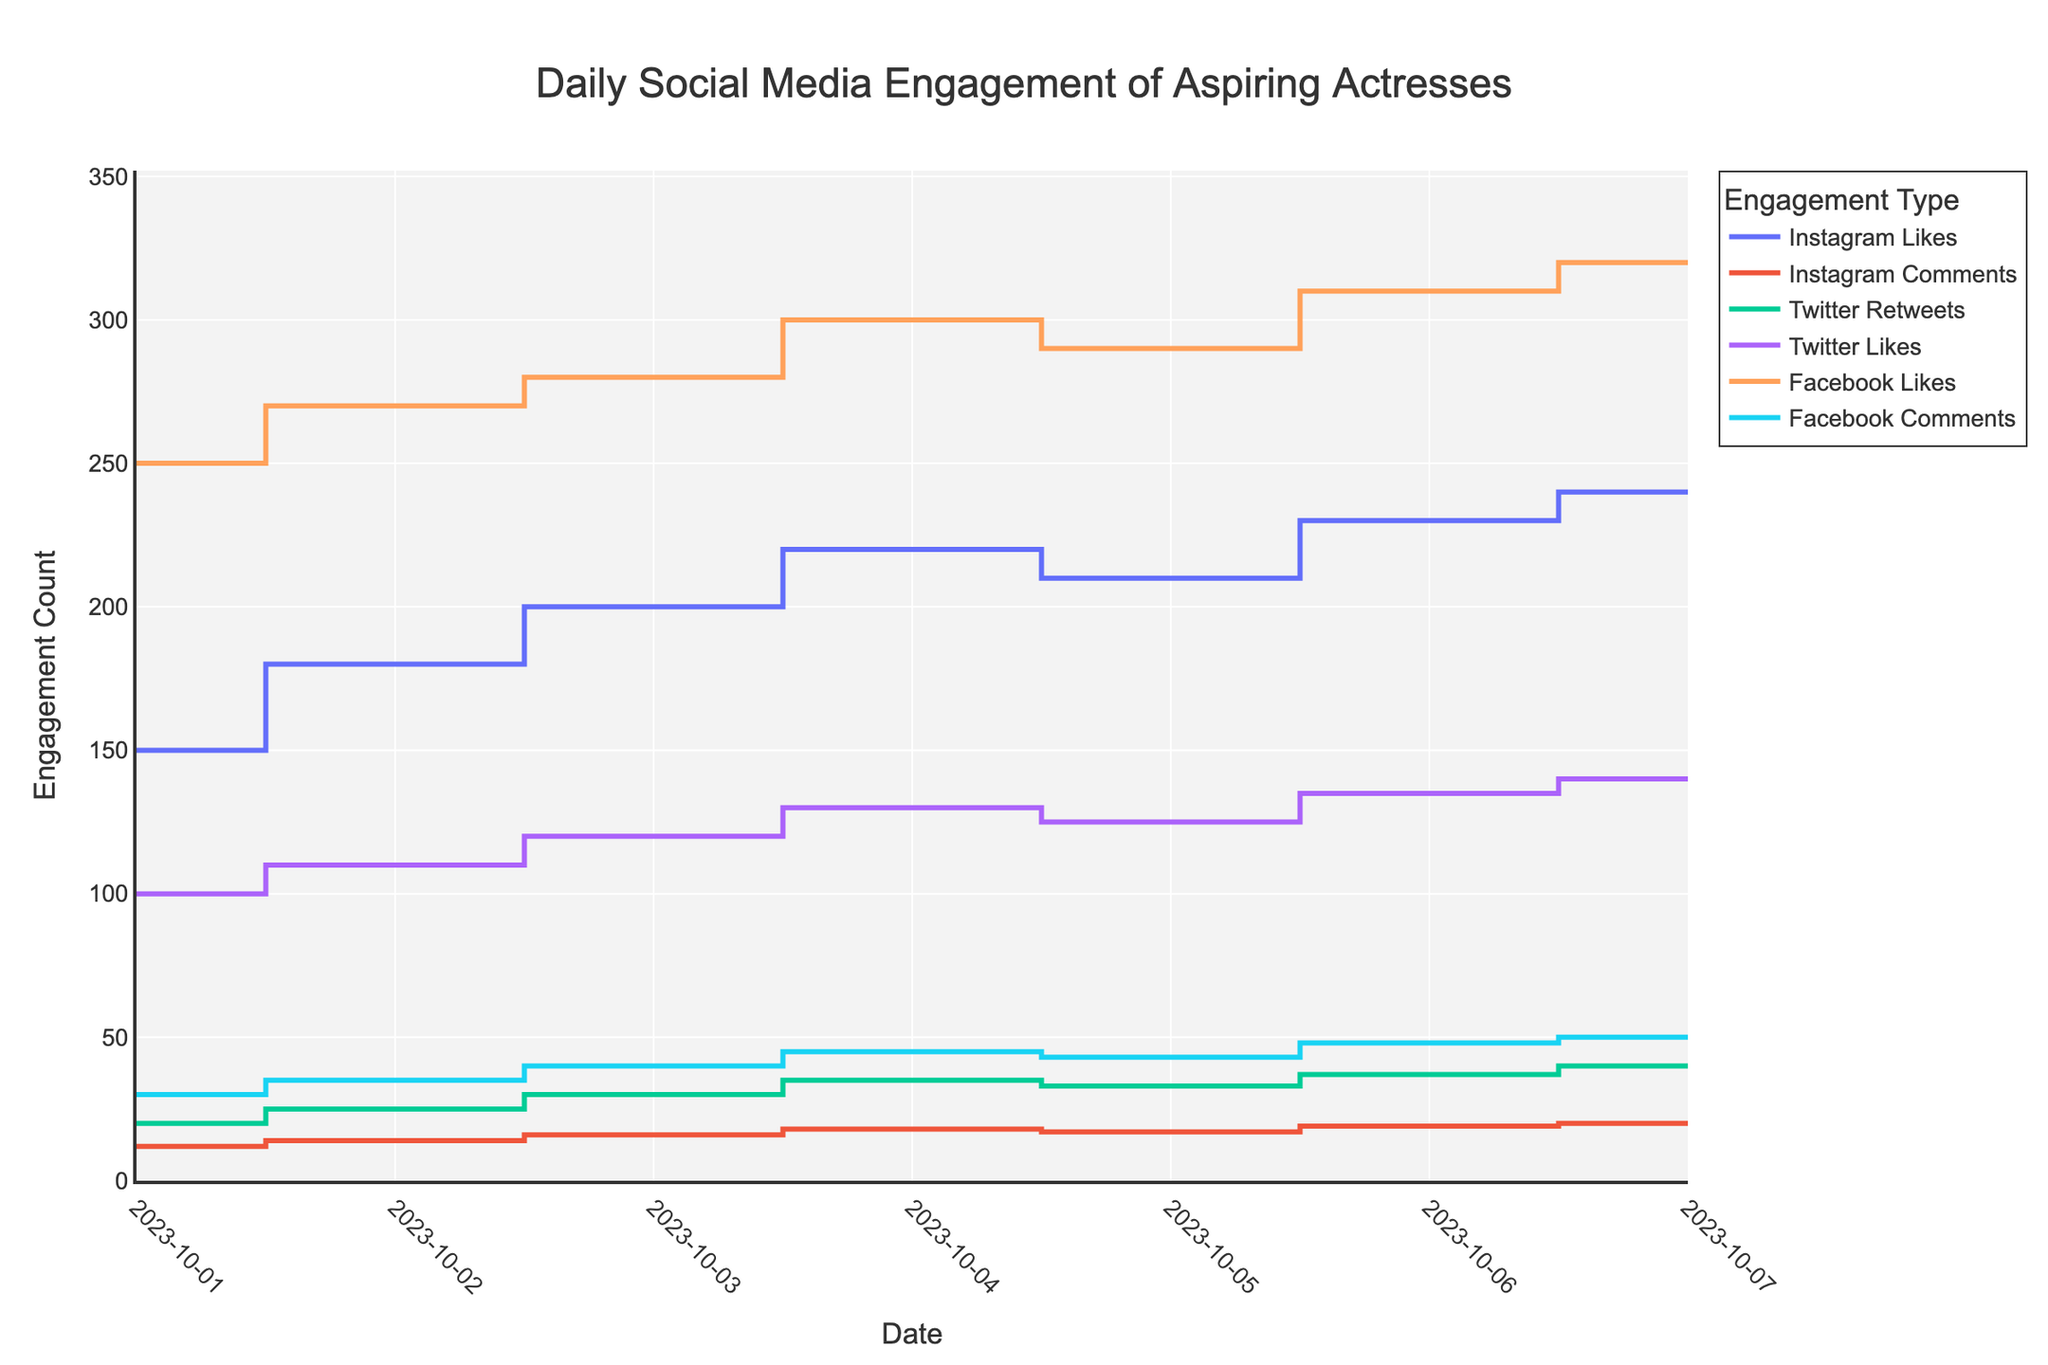What's the title of the plot? The title is located at the top of the figure and describes the main topic of the plot.
Answer: Daily Social Media Engagement of Aspiring Actresses What is the highest engagement count recorded for Instagram Likes? The highest point on the stair plot line for Instagram Likes gives us the value for the maximum engagement. It is reached on October 7 with a value of 240.
Answer: 240 Which social media platform had the highest number of comments on October 4? By observing the plot lines for comments on that date, you can see which platform's line reaches the highest value. Instagram and Facebook have comments, and the figure shows that Facebook has 45 while Instagram has 18.
Answer: Facebook How did Twitter Likes trend from October 1 to October 7? By following the line for Twitter Likes across the dates, you can see the overall pattern or trend in the values. The values start at 100 and progressively increase to 140, showing an upward trend.
Answer: Increasing What is the total engagement count for Facebook on October 3? Sum the Facebook Likes and Comments for October 3. The plot shows 280 Likes and 40 Comments for that date. The total is 280 + 40 = 320.
Answer: 320 Which day experienced the largest single-day increase in Instagram Comments? Look at the stair plot for Instagram Comments and find the largest increase by comparing consecutive days. The increase from October 3 to October 4 is the largest (16 to 18, a difference of 2).
Answer: October 4 What is the overall trend in Instagram Likes over the week? Observe the stair plot line for Instagram Likes from October 1 to October 7. It shows a steady upward trend overall, though there was a slight dip on October 5.
Answer: Upward trend On which day did Instagram Likes see a decrease from the previous day? By looking at the line for Instagram Likes, identify any point from October 1 to October 7 where the value decreases from one day to the next. This happened on October 5, reducing from 220 on October 4 to 210 on October 5.
Answer: October 5 What engagement type had the highest value on October 6? Compare the engagement values across all types for October 6. The highest is Facebook Likes with a value of 310.
Answer: Facebook Likes How many data points are there for each social media engagement type? Count the number of data points along each line on the stair plot. All engagement types have daily values from October 1 to October 7, which gives 7 data points each.
Answer: 7 